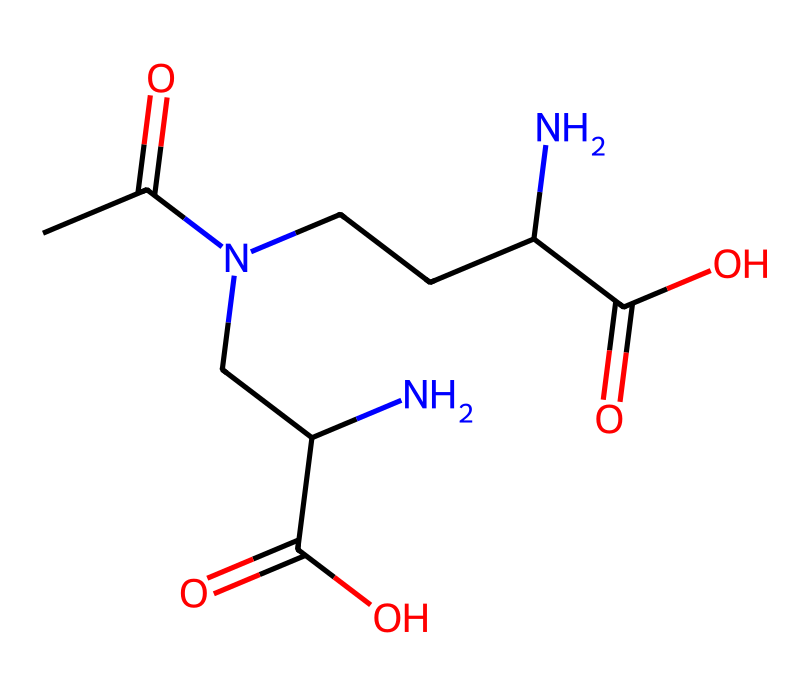What is the molecular formula of L-theanine? To determine the molecular formula, count the number of each type of atom represented in the SMILES string. The atoms included in the SMILES are carbon (C), hydrogen (H), nitrogen (N), and oxygen (O). The final tally reveals that L-theanine has 7 carbon atoms, 14 hydrogen atoms, 2 nitrogen atoms, and 3 oxygen atoms, leading to the molecular formula C7H14N2O3.
Answer: C7H14N2O3 How many nitrogen atoms are in L-theanine? By examining the SMILES representation, you can identify the presence of nitrogen (N) in the compound. There are two occurrences of nitrogen in the structure, which indicates that L-theanine contains two nitrogen atoms.
Answer: 2 What type of compound is L-theanine? L-theanine, based on its amino acid structure featuring both an amino group (–NH2) and a carboxylic acid group (–COOH), classifies it as an amino acid. This functional grouping primarily determines its classification.
Answer: amino acid Does L-theanine contain a carboxylic acid functional group? Observing the SMILES, we can identify the presence of a carboxylic acid functional group, characterized by the –COOH portion of the structure. Thus, L-theanine possesses a carboxylic acid group due to the structured representation in the SMILES notation.
Answer: yes What is the total number of hydrogen atoms in L-theanine? To find the total number of hydrogen atoms, you need to count the implied hydrogens associated with each atom in the structure based on typical valency (carbon typically forms four bonds, nitrogen three, and oxygen two). After analyzing the connections in the structure, we find a total of 14 hydrogen atoms.
Answer: 14 Is L-theanine considered a chiral molecule? To determine chirality, one must look for carbon atoms that are bonded to four different substituents. Analyzing the structure of L-theanine reveals that it contains a carbon atom bonded to two other identical groups, indicating that it does not have a chiral center and is therefore not a chiral molecule.
Answer: no 